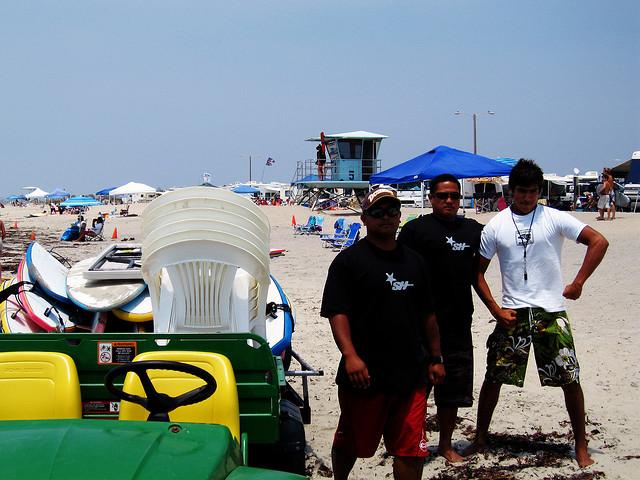How many of them are wearing shorts?
Be succinct. 3. What year is the John deere?
Answer briefly. 2010. What is the job of these men?
Be succinct. Lifeguards. Are both men standing up straight?
Short answer required. Yes. 